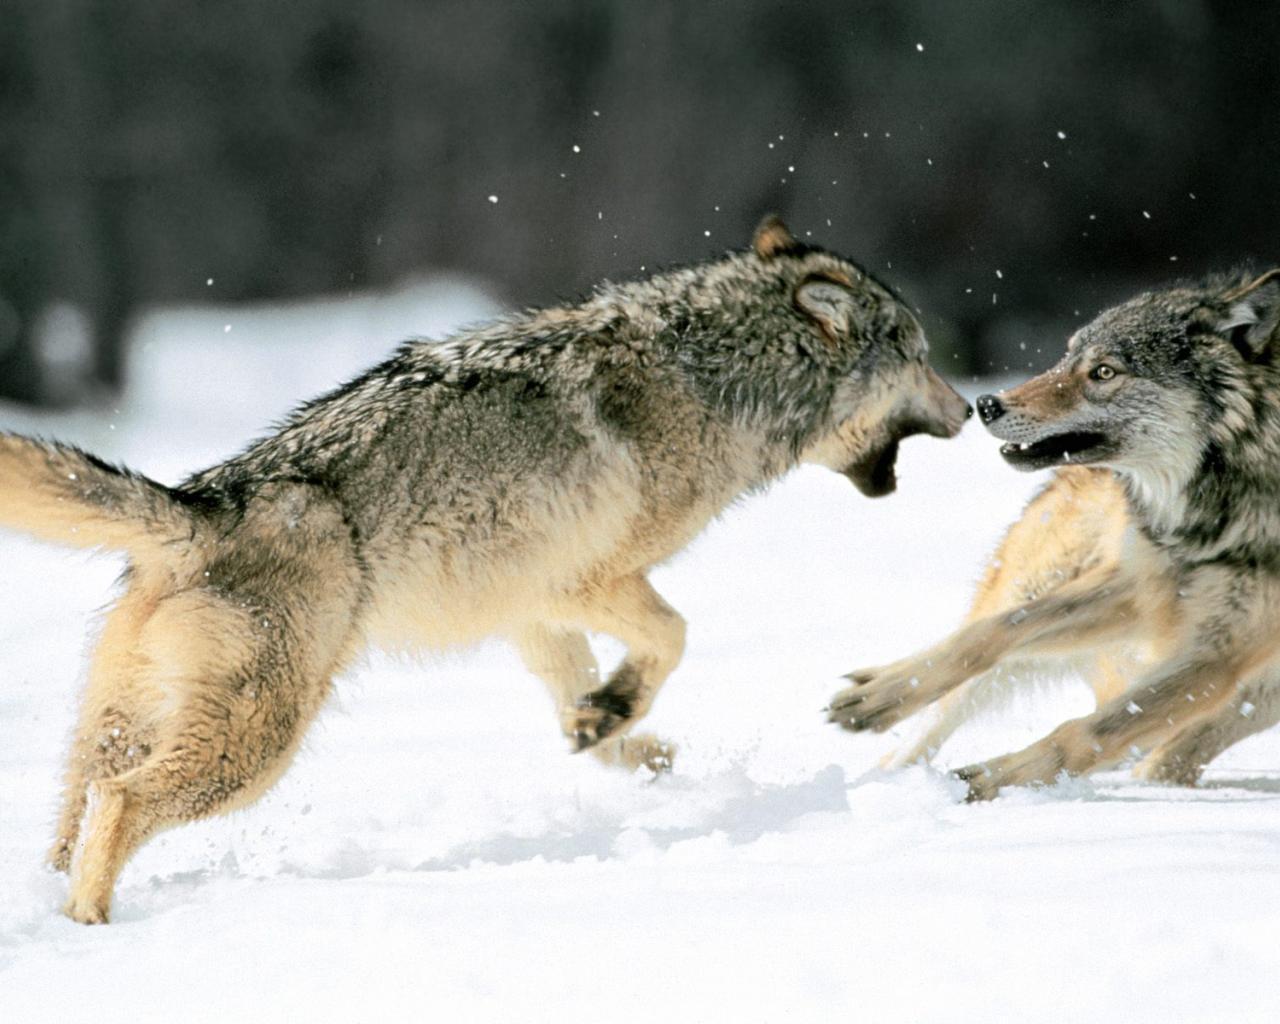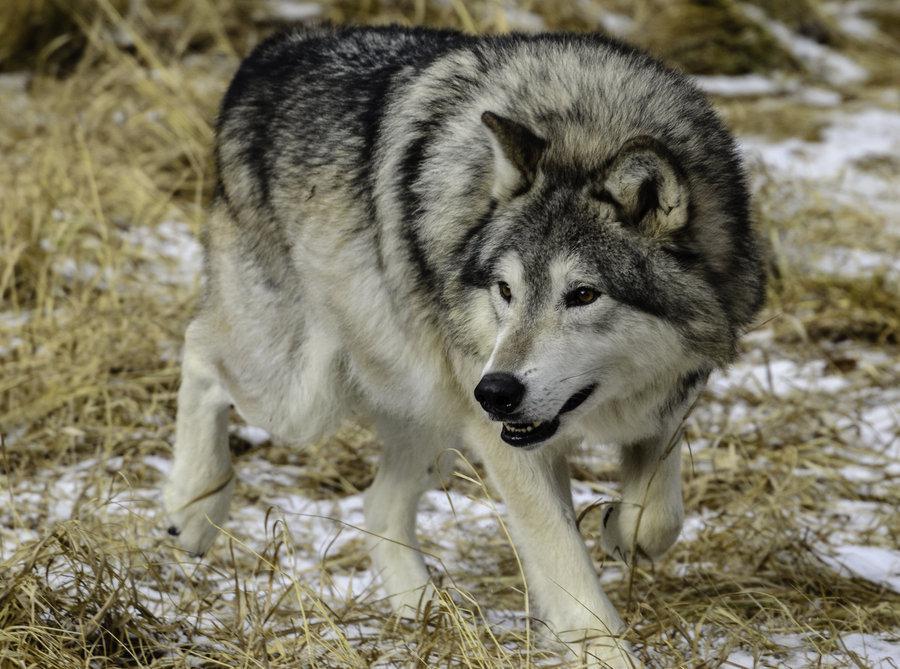The first image is the image on the left, the second image is the image on the right. Examine the images to the left and right. Is the description "There are two wolves snuggling in the right image." accurate? Answer yes or no. No. The first image is the image on the left, the second image is the image on the right. For the images displayed, is the sentence "In one of the pictures, two wolves are cuddling, and in the other, a wolf is alone and there is a tree or tree bark visible." factually correct? Answer yes or no. No. 